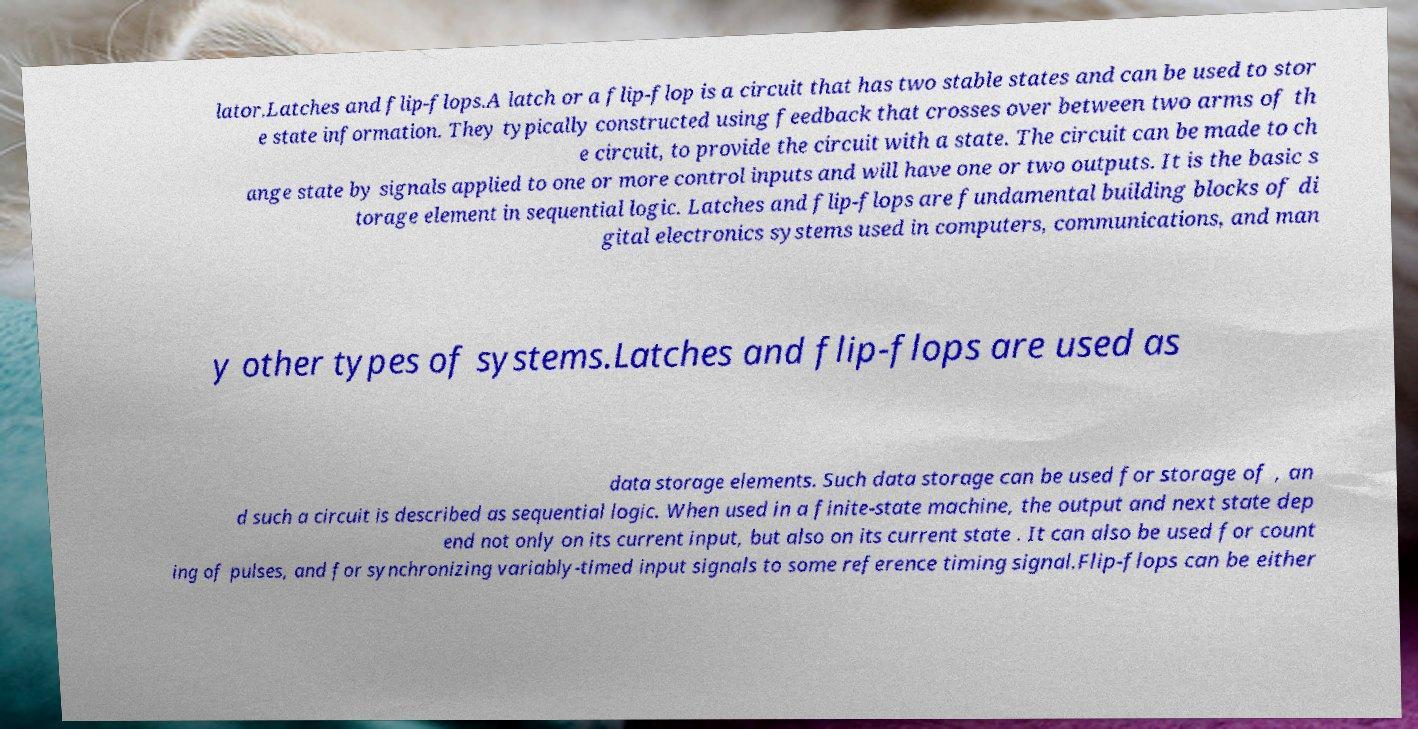What messages or text are displayed in this image? I need them in a readable, typed format. lator.Latches and flip-flops.A latch or a flip-flop is a circuit that has two stable states and can be used to stor e state information. They typically constructed using feedback that crosses over between two arms of th e circuit, to provide the circuit with a state. The circuit can be made to ch ange state by signals applied to one or more control inputs and will have one or two outputs. It is the basic s torage element in sequential logic. Latches and flip-flops are fundamental building blocks of di gital electronics systems used in computers, communications, and man y other types of systems.Latches and flip-flops are used as data storage elements. Such data storage can be used for storage of , an d such a circuit is described as sequential logic. When used in a finite-state machine, the output and next state dep end not only on its current input, but also on its current state . It can also be used for count ing of pulses, and for synchronizing variably-timed input signals to some reference timing signal.Flip-flops can be either 